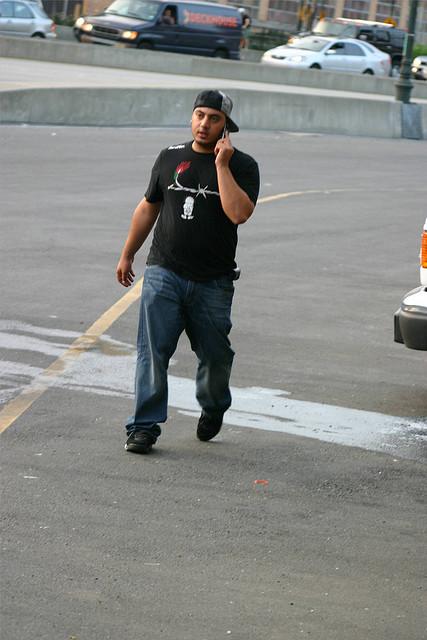Does he have a hat on?
Keep it brief. Yes. What is the man holding with the left hand?
Short answer required. Phone. Is there any car in the photo?
Concise answer only. Yes. 